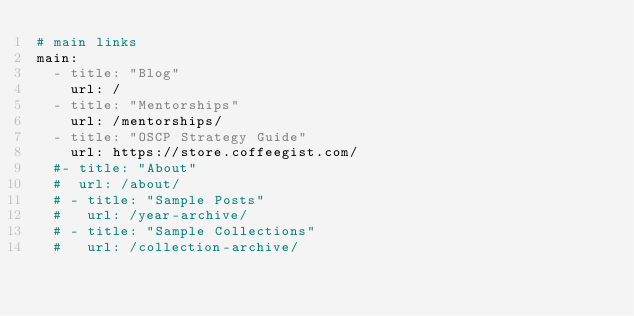<code> <loc_0><loc_0><loc_500><loc_500><_YAML_># main links
main:
  - title: "Blog"
    url: /
  - title: "Mentorships"
    url: /mentorships/
  - title: "OSCP Strategy Guide"
    url: https://store.coffeegist.com/
  #- title: "About"
  #  url: /about/
  # - title: "Sample Posts"
  #   url: /year-archive/
  # - title: "Sample Collections"
  #   url: /collection-archive/</code> 